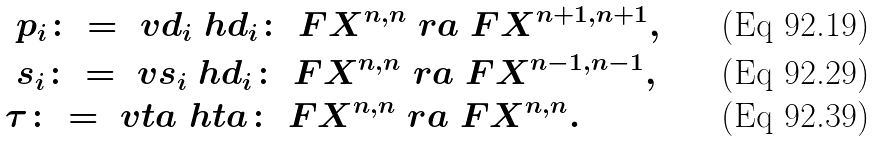Convert formula to latex. <formula><loc_0><loc_0><loc_500><loc_500>& \ p _ { i } \colon = \ v d _ { i } \ h d _ { i } \colon \ F X ^ { n , n } \ r a \ F X ^ { n + 1 , n + 1 } , \\ & \ s _ { i } \colon = \ v s _ { i } \ h d _ { i } \colon \ F X ^ { n , n } \ r a \ F X ^ { n - 1 , n - 1 } , \\ & \tau \colon = \ v t a \ h t a \colon \ F X ^ { n , n } \ r a \ F X ^ { n , n } .</formula> 